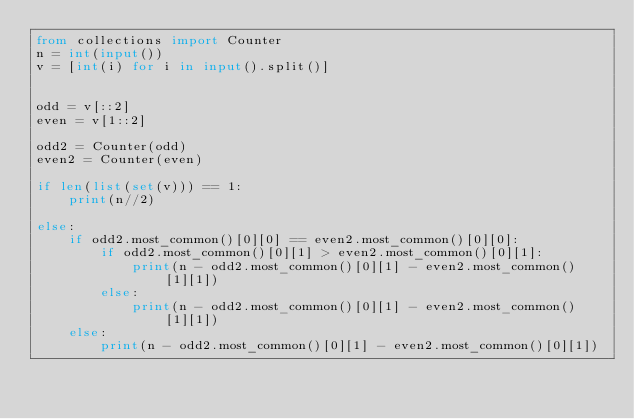<code> <loc_0><loc_0><loc_500><loc_500><_Python_>from collections import Counter
n = int(input())
v = [int(i) for i in input().split()]


odd = v[::2]
even = v[1::2]

odd2 = Counter(odd)
even2 = Counter(even)

if len(list(set(v))) == 1:
    print(n//2)

else:
    if odd2.most_common()[0][0] == even2.most_common()[0][0]:
        if odd2.most_common()[0][1] > even2.most_common()[0][1]:
            print(n - odd2.most_common()[0][1] - even2.most_common()[1][1])
        else:
            print(n - odd2.most_common()[0][1] - even2.most_common()[1][1])
    else:
        print(n - odd2.most_common()[0][1] - even2.most_common()[0][1])
</code> 